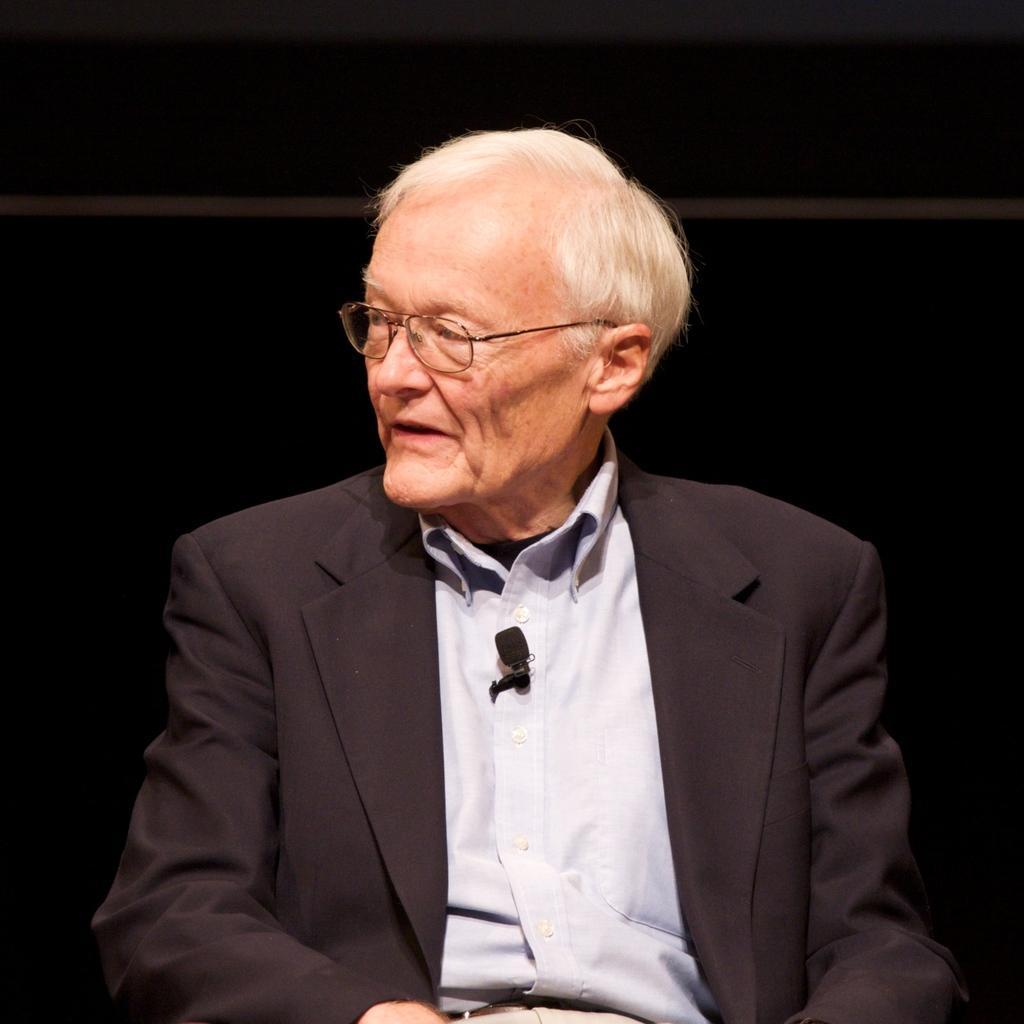In one or two sentences, can you explain what this image depicts? In this picture there is a man wore spectacle. In the background of the image it is dark. 